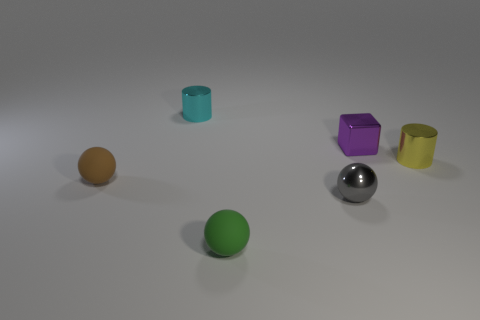Add 2 large brown spheres. How many objects exist? 8 Subtract all cylinders. How many objects are left? 4 Add 5 small matte objects. How many small matte objects are left? 7 Add 1 large purple metal cylinders. How many large purple metal cylinders exist? 1 Subtract 0 purple spheres. How many objects are left? 6 Subtract all tiny yellow cylinders. Subtract all tiny purple shiny things. How many objects are left? 4 